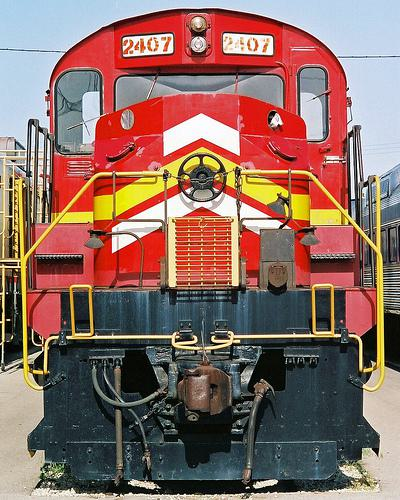How many unicorns are there in the image? There are no unicorns visible in the image, as it features a vibrant red and yellow train, showing no mythical or fantastical elements. 